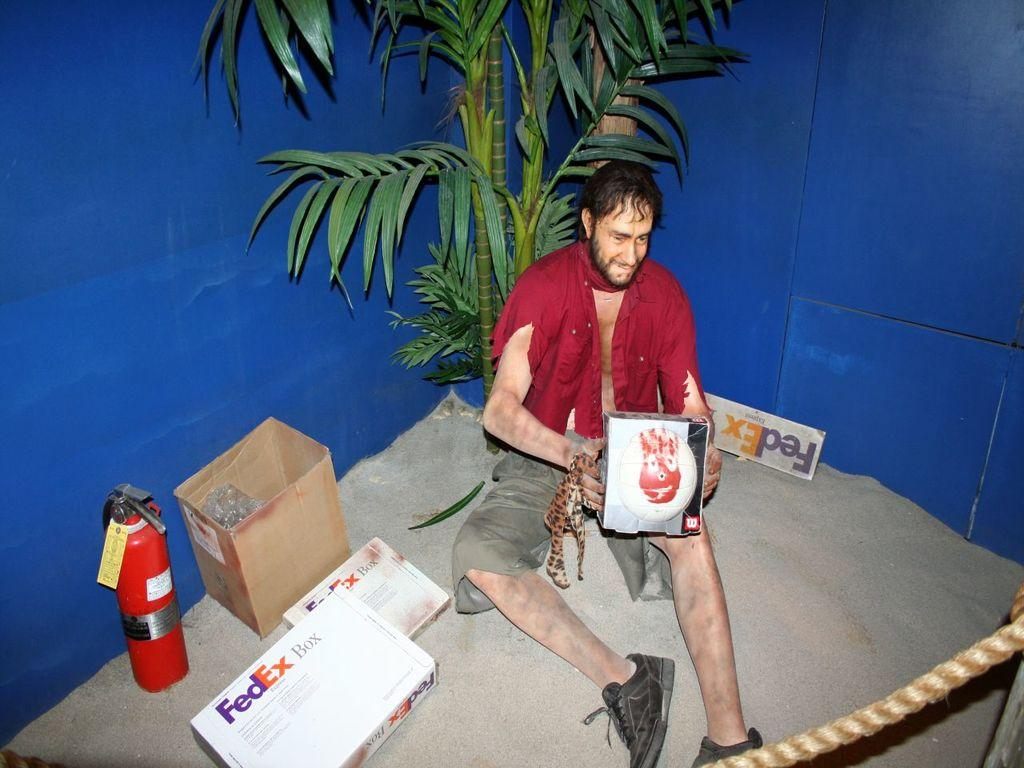What is the person in the image doing? The person is sitting on the ground in the image. What type of boxes can be seen at the bottom of the image? There are two FedEx boxes at the bottom of the image. What shape is the object in the image? There is a cylinder in the image. What type of container is present in the image? There is a carton box in the image. What color is the background of the image? The background of the image is blue. What type of plant is in the middle of the image? There is a plant in the middle of the image. What type of creature is using the basin in the image? There is no creature or basin present in the image. What is the condition of the plant in the image? The provided facts do not mention the condition of the plant, so we cannot determine its condition from the image. 